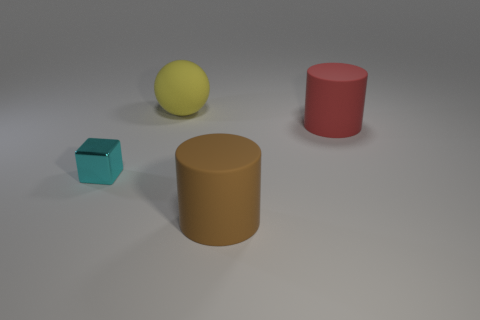What kind of material do the objects look like they're made of? The objects in the image appear to be made of a matte material, possibly plastic or rubber, given their smooth surface and the way they reflect light. 